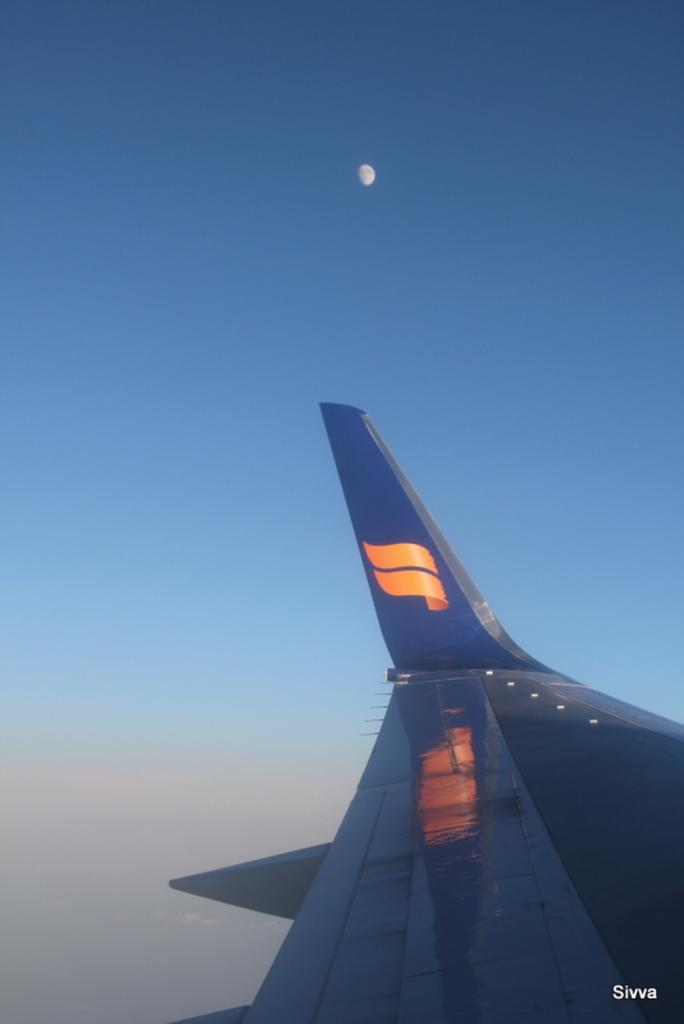What is the main subject of the image? The main subject of the image is a wing of a plane. What can be seen in the background of the image? There is a sky in the background of the image. What celestial object is visible at the top of the image? There is a moon at the top of the image. How many pigs are visible in the image? There are no pigs present in the image. What type of property is shown in the image? The image does not depict any property; it features a wing of a plane, a sky, and a moon. 